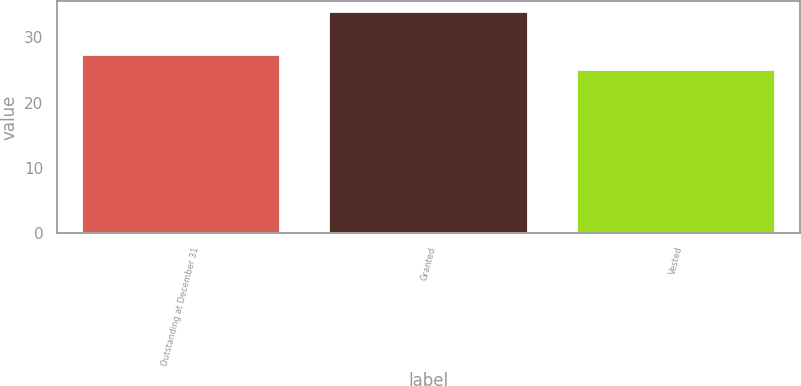<chart> <loc_0><loc_0><loc_500><loc_500><bar_chart><fcel>Outstanding at December 31<fcel>Granted<fcel>Vested<nl><fcel>27.31<fcel>33.85<fcel>25.07<nl></chart> 